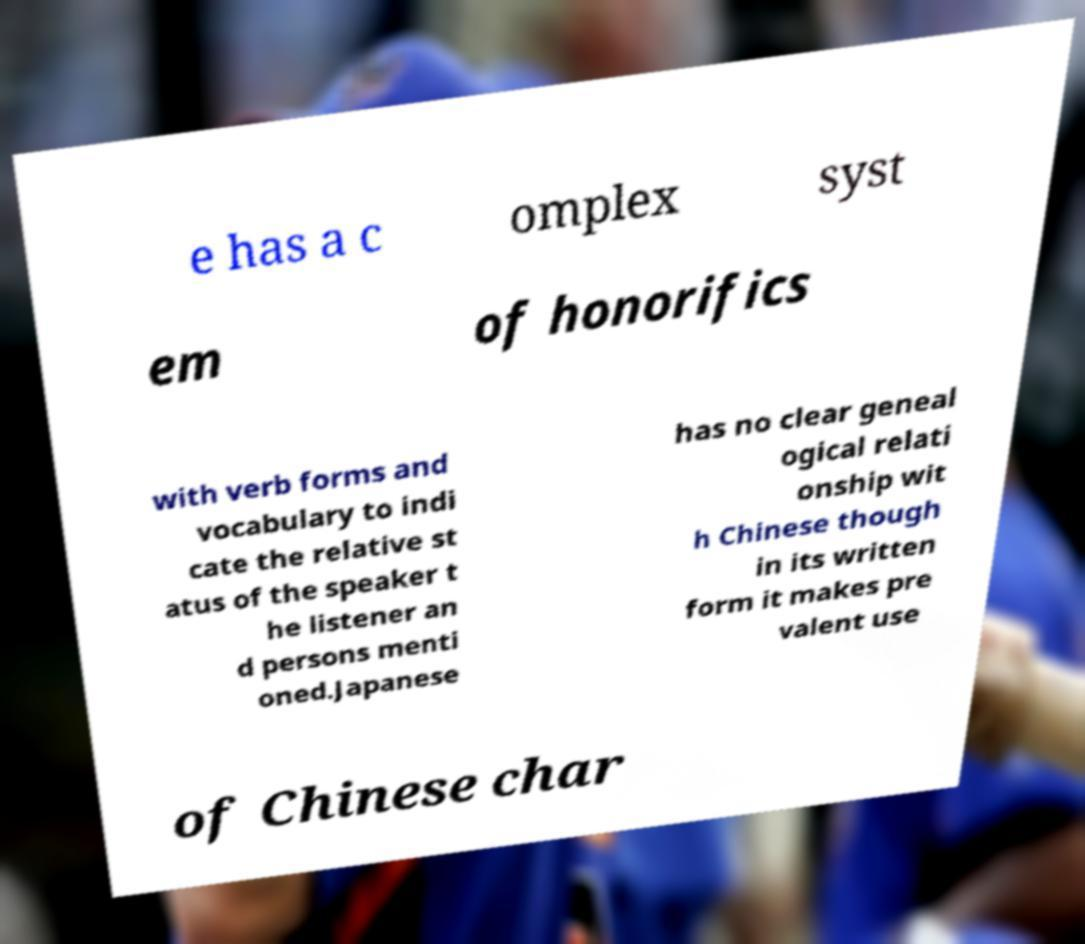There's text embedded in this image that I need extracted. Can you transcribe it verbatim? e has a c omplex syst em of honorifics with verb forms and vocabulary to indi cate the relative st atus of the speaker t he listener an d persons menti oned.Japanese has no clear geneal ogical relati onship wit h Chinese though in its written form it makes pre valent use of Chinese char 